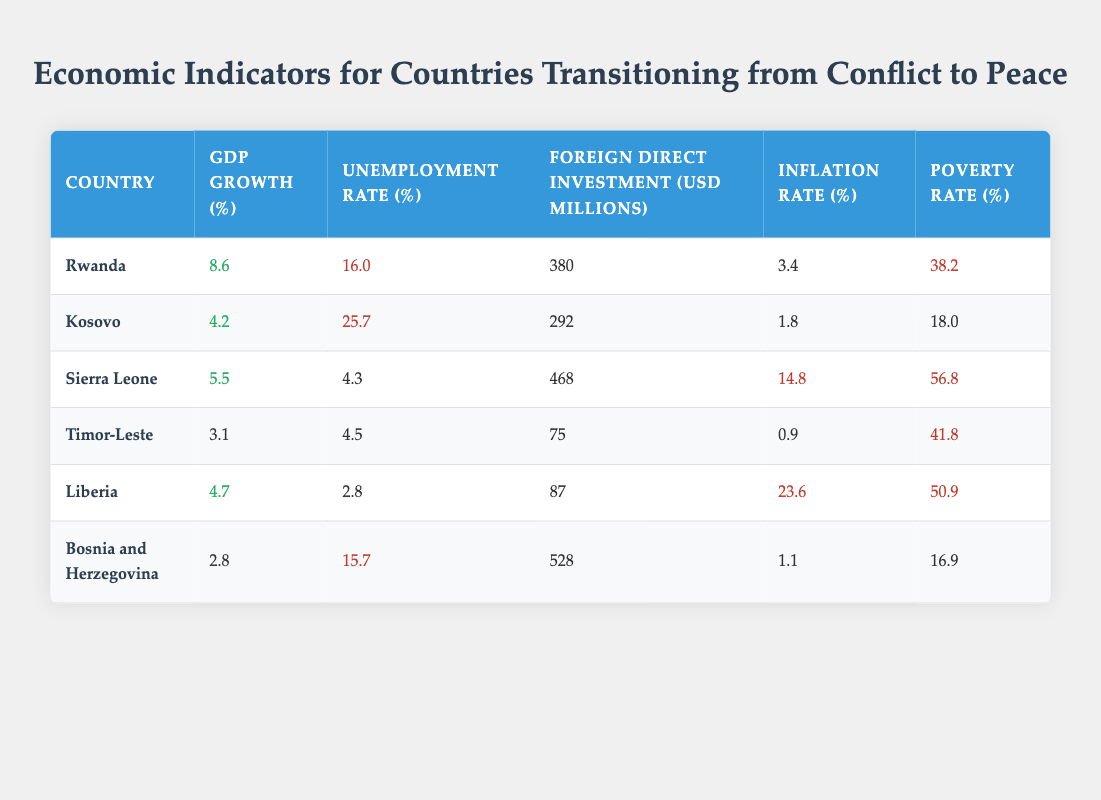What is the GDP growth rate of Rwanda? According to the table, Rwanda has a GDP growth rate of 8.6%.
Answer: 8.6% Which country has the highest unemployment rate? The table shows that Kosovo has the highest unemployment rate at 25.7%.
Answer: Kosovo What is the average poverty rate of the countries listed? To find the average, sum the poverty rates: (38.2 + 18.0 + 56.8 + 41.8 + 50.9 + 16.9) = 222.6. There are 6 countries, so the average is 222.6/6 = 37.1.
Answer: 37.1 Is the inflation rate in Liberia greater than the inflation rate in Bosnia and Herzegovina? Liberia has an inflation rate of 23.6% while Bosnia and Herzegovina has an inflation rate of 1.1%. Since 23.6 is greater than 1.1, the statement is true.
Answer: Yes What is the difference in Foreign Direct Investment between Sierra Leone and Timor-Leste? Sierra Leone has a Foreign Direct Investment of 468 million USD, while Timor-Leste has 75 million USD. The difference is 468 - 75 = 393 million USD.
Answer: 393 million USD Which country has the lowest GDP growth rate? Scanning through the table, Bosnia and Herzegovina has the lowest GDP growth rate at 2.8%.
Answer: Bosnia and Herzegovina How many countries have a poverty rate higher than 50%? From the table, Sierra Leone (56.8%) and Liberia (50.9%) have a poverty rate higher than 50%. Therefore, there are 2 countries.
Answer: 2 What is the total Foreign Direct Investment for all countries listed? The total is calculated by adding all the Foreign Direct Investment values: 380 + 292 + 468 + 75 + 87 + 528 = 1830 million USD.
Answer: 1830 million USD 